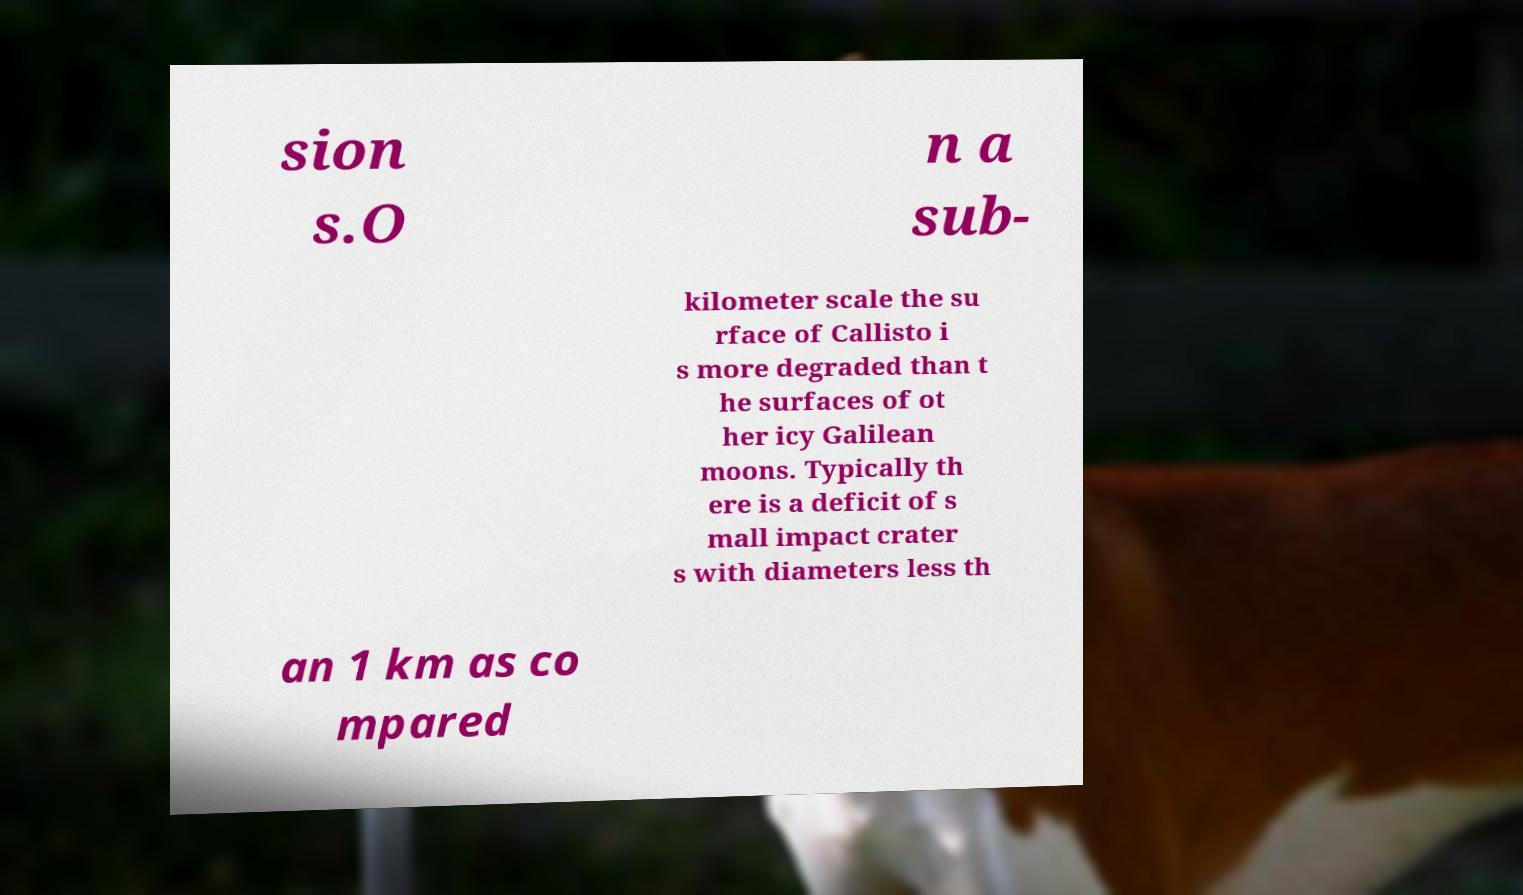Could you assist in decoding the text presented in this image and type it out clearly? sion s.O n a sub- kilometer scale the su rface of Callisto i s more degraded than t he surfaces of ot her icy Galilean moons. Typically th ere is a deficit of s mall impact crater s with diameters less th an 1 km as co mpared 